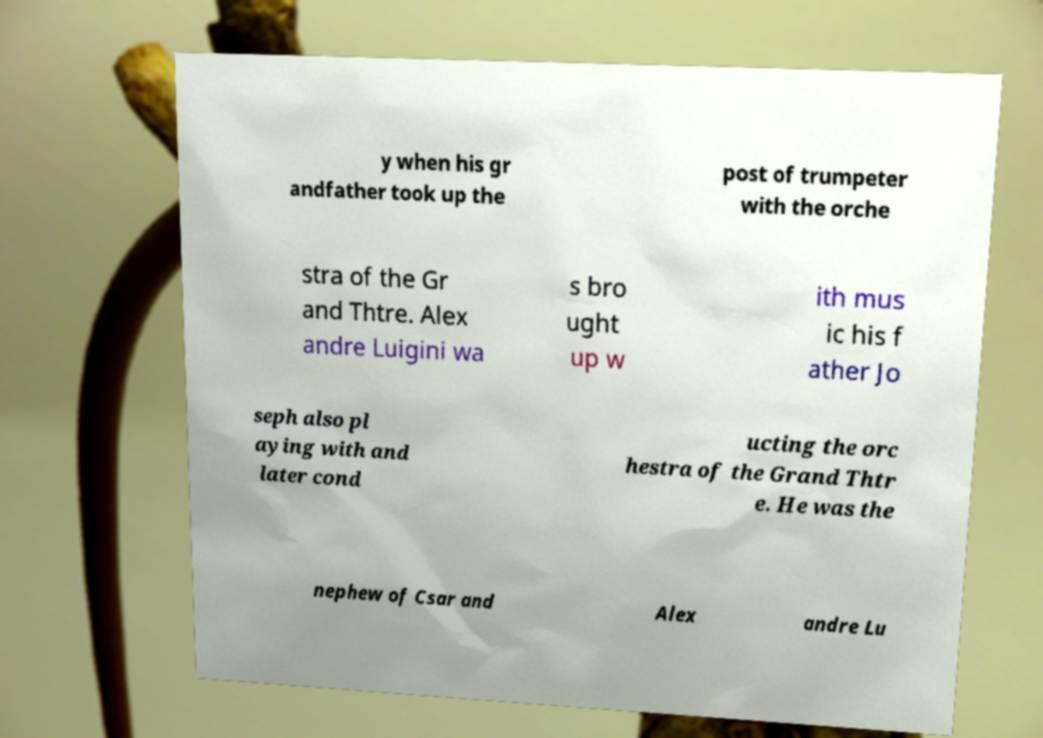Can you accurately transcribe the text from the provided image for me? y when his gr andfather took up the post of trumpeter with the orche stra of the Gr and Thtre. Alex andre Luigini wa s bro ught up w ith mus ic his f ather Jo seph also pl aying with and later cond ucting the orc hestra of the Grand Thtr e. He was the nephew of Csar and Alex andre Lu 